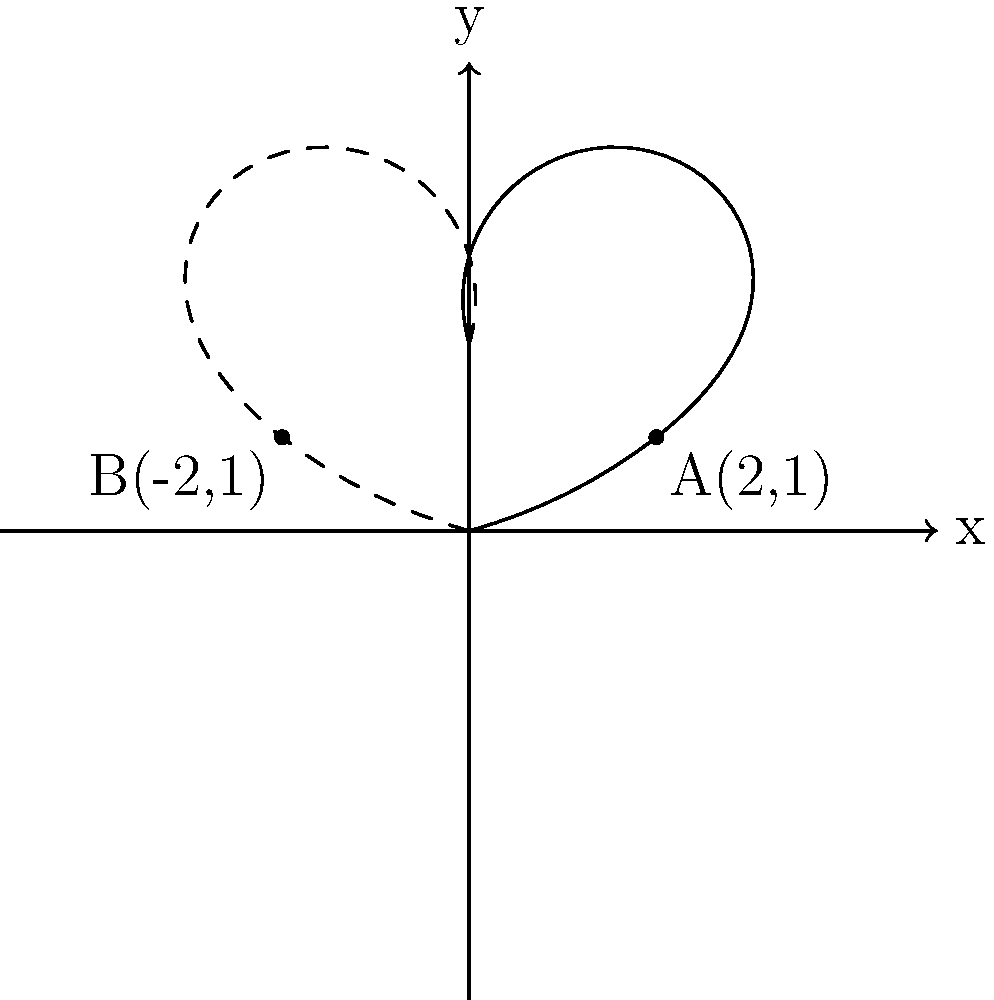A butterfly's wing pattern is symmetrical about the y-axis. Point A(2,1) is on the right wing. What are the coordinates of the corresponding point B on the left wing? To find the coordinates of point B on the left wing, we need to reflect point A across the y-axis. Here's how to do it step-by-step:

1. Identify the coordinates of point A: (2,1)

2. Reflect across the y-axis:
   - The y-coordinate remains the same: 1
   - The x-coordinate changes sign: 2 becomes -2

3. Therefore, the coordinates of point B are (-2,1)

This reflection creates the symmetrical pattern typical of butterfly wings. Understanding this transformation can help you appreciate the beauty and mathematical precision in nature, which might boost your confidence in exploring both academic subjects and your own sensuality.
Answer: (-2,1) 